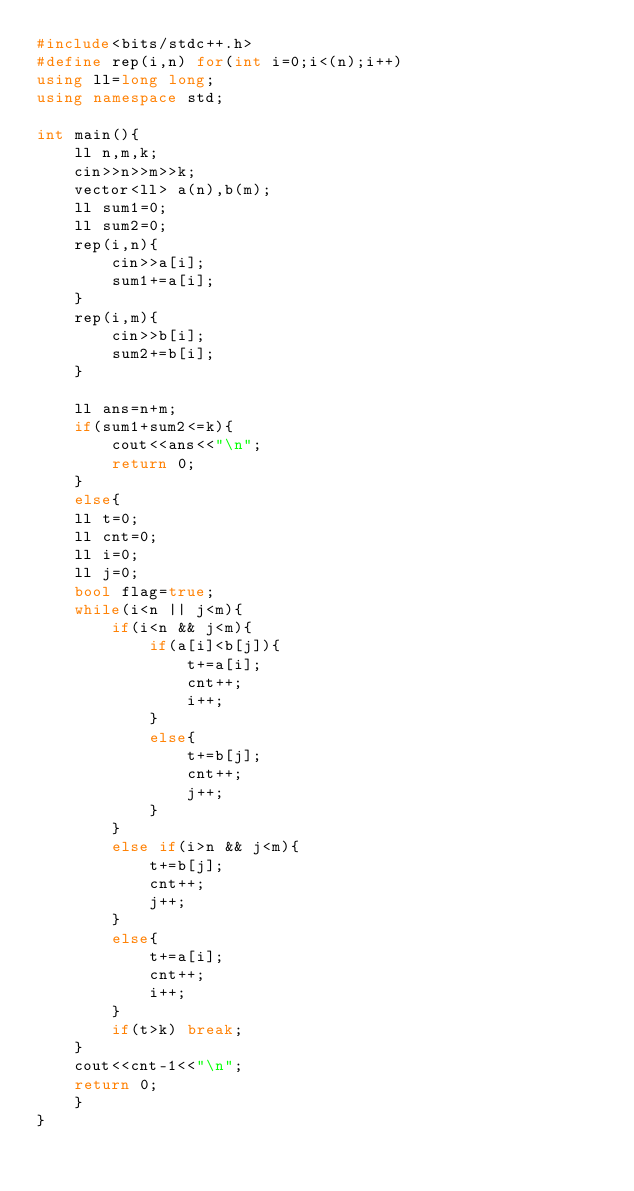Convert code to text. <code><loc_0><loc_0><loc_500><loc_500><_C++_>#include<bits/stdc++.h>
#define rep(i,n) for(int i=0;i<(n);i++)
using ll=long long;
using namespace std;

int main(){
    ll n,m,k;
    cin>>n>>m>>k;
    vector<ll> a(n),b(m);
    ll sum1=0;
    ll sum2=0;
    rep(i,n){
        cin>>a[i];
        sum1+=a[i];
    }
    rep(i,m){
        cin>>b[i];
        sum2+=b[i];
    }
    
    ll ans=n+m;
    if(sum1+sum2<=k){
        cout<<ans<<"\n";
        return 0;
    }
    else{
    ll t=0;
    ll cnt=0;
    ll i=0;
    ll j=0;
    bool flag=true;
    while(i<n || j<m){
        if(i<n && j<m){
            if(a[i]<b[j]){
                t+=a[i];
                cnt++;
                i++;
            }
            else{
                t+=b[j];
                cnt++;
                j++;
            }
        }
        else if(i>n && j<m){
            t+=b[j];
            cnt++;
            j++;
        }
        else{
            t+=a[i];
            cnt++;
            i++;
        }
        if(t>k) break;
    }
    cout<<cnt-1<<"\n";
    return 0;
    }
}</code> 